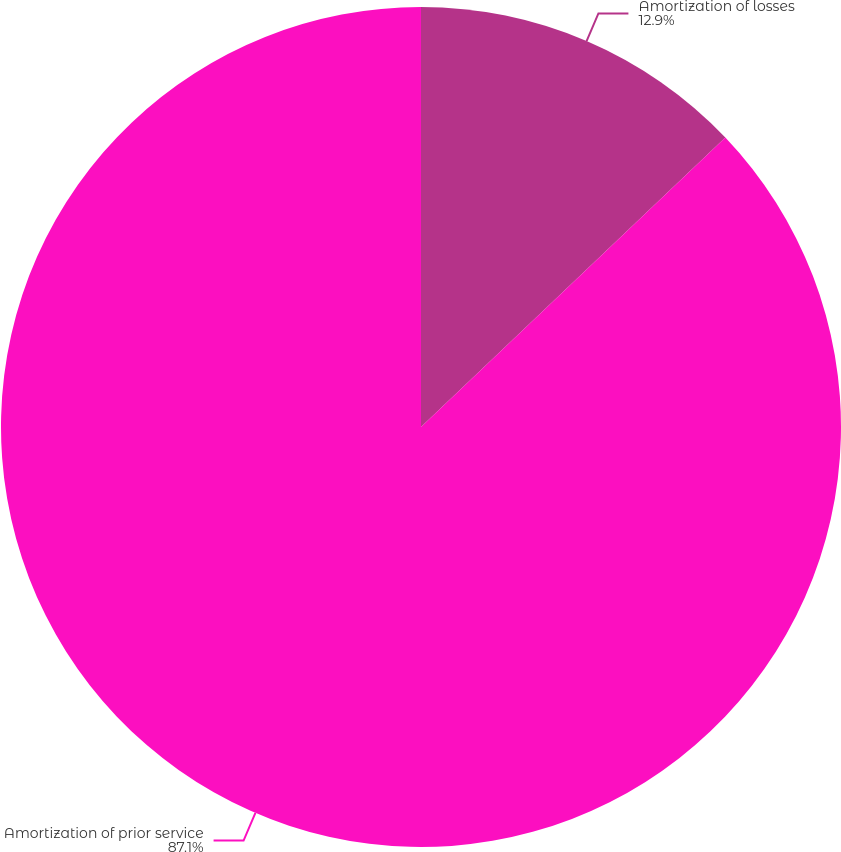Convert chart. <chart><loc_0><loc_0><loc_500><loc_500><pie_chart><fcel>Amortization of losses<fcel>Amortization of prior service<nl><fcel>12.9%<fcel>87.1%<nl></chart> 